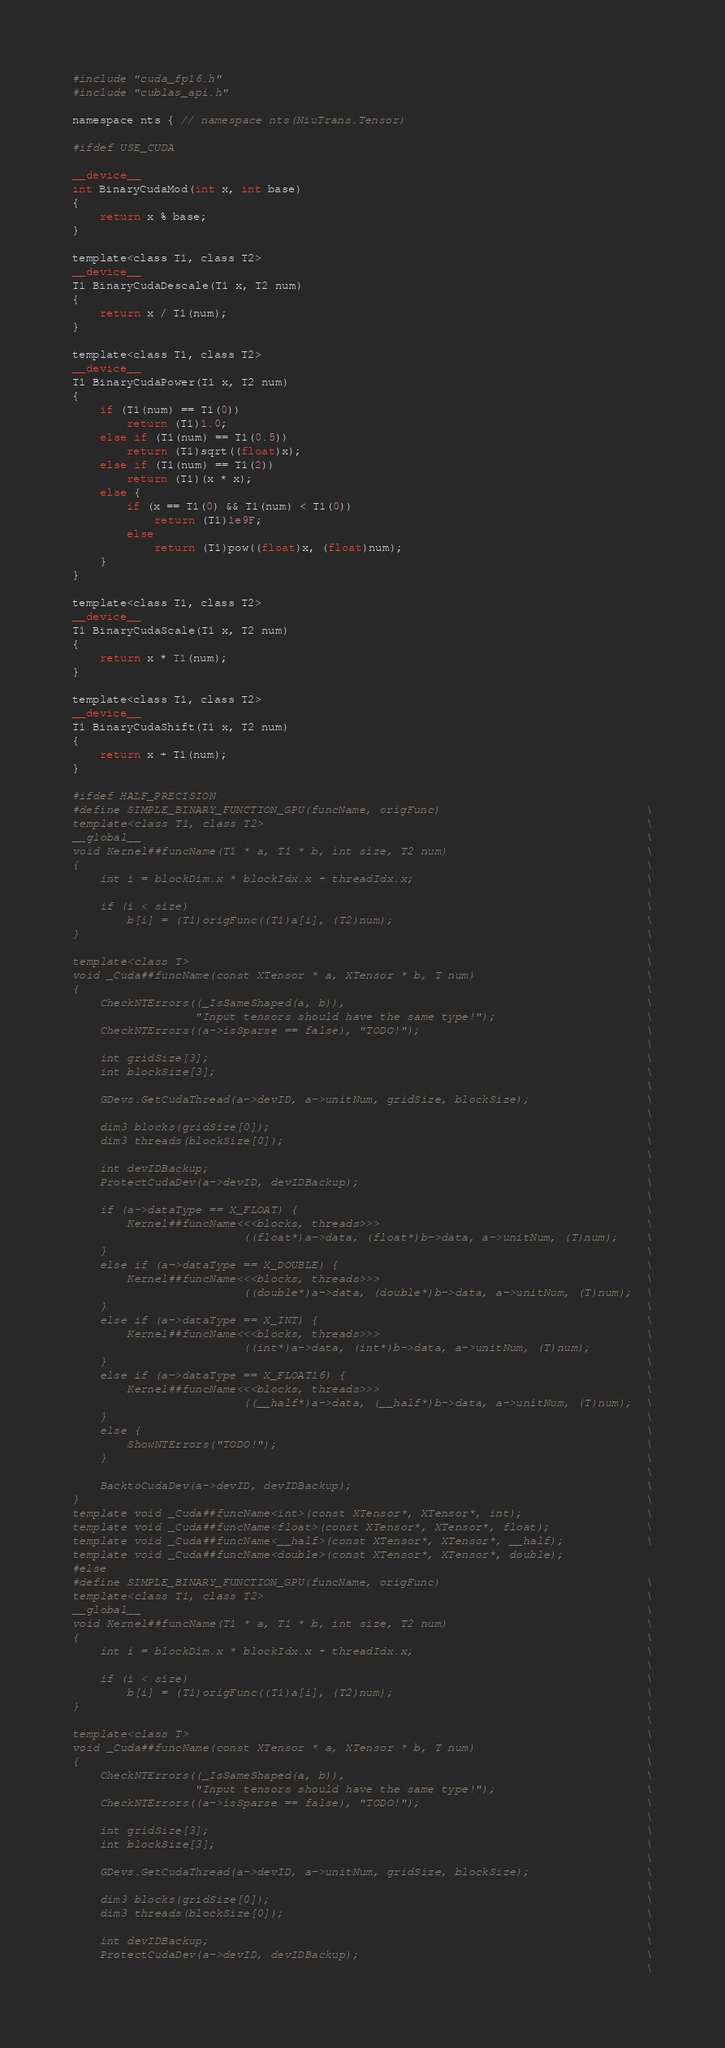<code> <loc_0><loc_0><loc_500><loc_500><_Cuda_>#include "cuda_fp16.h"
#include "cublas_api.h"

namespace nts { // namespace nts(NiuTrans.Tensor)

#ifdef USE_CUDA
    
__device__
int BinaryCudaMod(int x, int base)
{
    return x % base;
}

template<class T1, class T2>
__device__
T1 BinaryCudaDescale(T1 x, T2 num)
{
    return x / T1(num);
}

template<class T1, class T2>
__device__
T1 BinaryCudaPower(T1 x, T2 num)
{
    if (T1(num) == T1(0))
        return (T1)1.0;
    else if (T1(num) == T1(0.5))
        return (T1)sqrt((float)x);
    else if (T1(num) == T1(2))
        return (T1)(x * x);
    else {
        if (x == T1(0) && T1(num) < T1(0))
            return (T1)1e9F;
        else
            return (T1)pow((float)x, (float)num);
    }
}

template<class T1, class T2>
__device__
T1 BinaryCudaScale(T1 x, T2 num)
{
    return x * T1(num);
}

template<class T1, class T2>
__device__
T1 BinaryCudaShift(T1 x, T2 num)
{
    return x + T1(num);
}

#ifdef HALF_PRECISION
#define SIMPLE_BINARY_FUNCTION_GPU(funcName, origFunc)                              \
template<class T1, class T2>                                                        \
__global__                                                                          \
void Kernel##funcName(T1 * a, T1 * b, int size, T2 num)                             \
{                                                                                   \
    int i = blockDim.x * blockIdx.x + threadIdx.x;                                  \
                                                                                    \
    if (i < size)                                                                   \
        b[i] = (T1)origFunc((T1)a[i], (T2)num);                                     \
}                                                                                   \
                                                                                    \
template<class T>                                                                   \
void _Cuda##funcName(const XTensor * a, XTensor * b, T num)                         \
{                                                                                   \
    CheckNTErrors((_IsSameShaped(a, b)),                                            \
                  "Input tensors should have the same type!");                      \
    CheckNTErrors((a->isSparse == false), "TODO!");                                 \
                                                                                    \
    int gridSize[3];                                                                \
    int blockSize[3];                                                               \
                                                                                    \
    GDevs.GetCudaThread(a->devID, a->unitNum, gridSize, blockSize);                 \
                                                                                    \
    dim3 blocks(gridSize[0]);                                                       \
    dim3 threads(blockSize[0]);                                                     \
                                                                                    \
    int devIDBackup;                                                                \
    ProtectCudaDev(a->devID, devIDBackup);                                          \
                                                                                    \
    if (a->dataType == X_FLOAT) {                                                   \
        Kernel##funcName<<<blocks, threads>>>                                       \
                         ((float*)a->data, (float*)b->data, a->unitNum, (T)num);    \
    }                                                                               \
    else if (a->dataType == X_DOUBLE) {                                             \
        Kernel##funcName<<<blocks, threads>>>                                       \
                         ((double*)a->data, (double*)b->data, a->unitNum, (T)num);  \
    }                                                                               \
    else if (a->dataType == X_INT) {                                                \
        Kernel##funcName<<<blocks, threads>>>                                       \
                         ((int*)a->data, (int*)b->data, a->unitNum, (T)num);        \
    }                                                                               \
    else if (a->dataType == X_FLOAT16) {                                            \
        Kernel##funcName<<<blocks, threads>>>                                       \
                         ((__half*)a->data, (__half*)b->data, a->unitNum, (T)num);  \
    }                                                                               \
    else {                                                                          \
        ShowNTErrors("TODO!");                                                      \
    }                                                                               \
                                                                                    \
    BacktoCudaDev(a->devID, devIDBackup);                                           \
}                                                                                   \
template void _Cuda##funcName<int>(const XTensor*, XTensor*, int);                  \
template void _Cuda##funcName<float>(const XTensor*, XTensor*, float);              \
template void _Cuda##funcName<__half>(const XTensor*, XTensor*, __half);            \
template void _Cuda##funcName<double>(const XTensor*, XTensor*, double);            
#else
#define SIMPLE_BINARY_FUNCTION_GPU(funcName, origFunc)                              \
template<class T1, class T2>                                                        \
__global__                                                                          \
void Kernel##funcName(T1 * a, T1 * b, int size, T2 num)                             \
{                                                                                   \
    int i = blockDim.x * blockIdx.x + threadIdx.x;                                  \
                                                                                    \
    if (i < size)                                                                   \
        b[i] = (T1)origFunc((T1)a[i], (T2)num);                                     \
}                                                                                   \
                                                                                    \
template<class T>                                                                   \
void _Cuda##funcName(const XTensor * a, XTensor * b, T num)                         \
{                                                                                   \
    CheckNTErrors((_IsSameShaped(a, b)),                                            \
                  "Input tensors should have the same type!");                      \
    CheckNTErrors((a->isSparse == false), "TODO!");                                 \
                                                                                    \
    int gridSize[3];                                                                \
    int blockSize[3];                                                               \
                                                                                    \
    GDevs.GetCudaThread(a->devID, a->unitNum, gridSize, blockSize);                 \
                                                                                    \
    dim3 blocks(gridSize[0]);                                                       \
    dim3 threads(blockSize[0]);                                                     \
                                                                                    \
    int devIDBackup;                                                                \
    ProtectCudaDev(a->devID, devIDBackup);                                          \
                                                                                    \</code> 